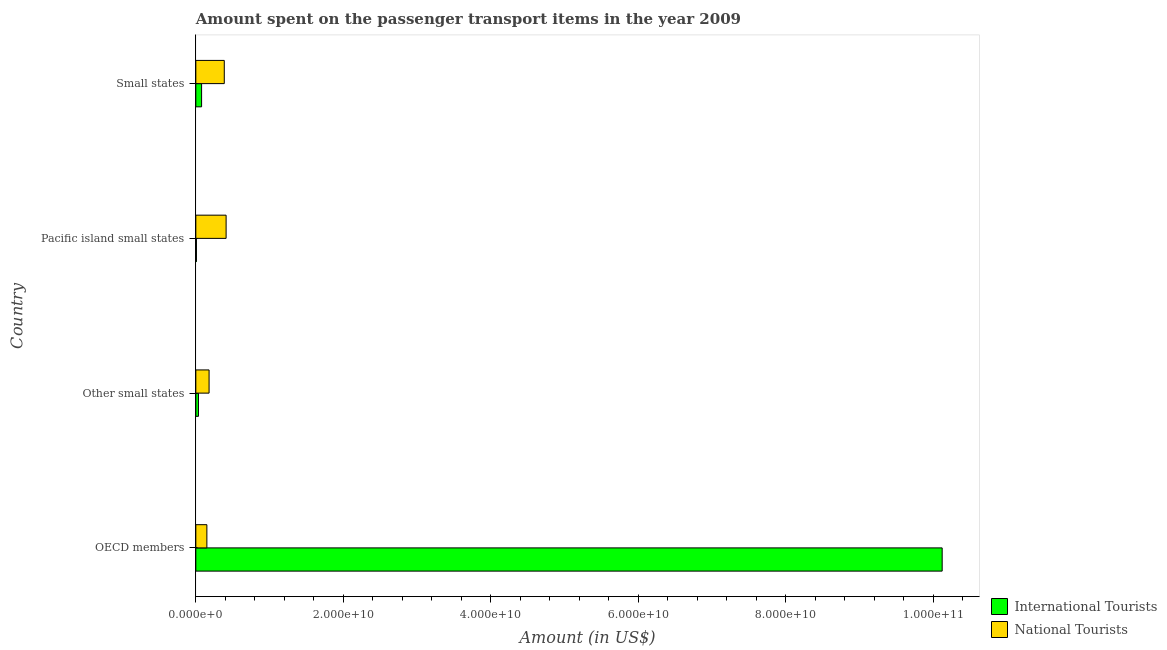How many different coloured bars are there?
Offer a very short reply. 2. How many groups of bars are there?
Your answer should be very brief. 4. How many bars are there on the 2nd tick from the top?
Provide a succinct answer. 2. How many bars are there on the 1st tick from the bottom?
Your answer should be compact. 2. What is the label of the 2nd group of bars from the top?
Give a very brief answer. Pacific island small states. What is the amount spent on transport items of international tourists in Small states?
Provide a succinct answer. 7.81e+08. Across all countries, what is the maximum amount spent on transport items of international tourists?
Offer a very short reply. 1.01e+11. Across all countries, what is the minimum amount spent on transport items of international tourists?
Give a very brief answer. 8.34e+07. In which country was the amount spent on transport items of international tourists maximum?
Offer a terse response. OECD members. In which country was the amount spent on transport items of international tourists minimum?
Give a very brief answer. Pacific island small states. What is the total amount spent on transport items of international tourists in the graph?
Keep it short and to the point. 1.02e+11. What is the difference between the amount spent on transport items of international tourists in OECD members and that in Other small states?
Give a very brief answer. 1.01e+11. What is the difference between the amount spent on transport items of national tourists in Pacific island small states and the amount spent on transport items of international tourists in OECD members?
Offer a very short reply. -9.71e+1. What is the average amount spent on transport items of national tourists per country?
Offer a very short reply. 2.82e+09. What is the difference between the amount spent on transport items of international tourists and amount spent on transport items of national tourists in Pacific island small states?
Your answer should be very brief. -4.02e+09. What is the ratio of the amount spent on transport items of national tourists in Other small states to that in Small states?
Provide a succinct answer. 0.47. What is the difference between the highest and the second highest amount spent on transport items of international tourists?
Ensure brevity in your answer.  1.00e+11. What is the difference between the highest and the lowest amount spent on transport items of national tourists?
Offer a very short reply. 2.61e+09. In how many countries, is the amount spent on transport items of international tourists greater than the average amount spent on transport items of international tourists taken over all countries?
Your answer should be compact. 1. Is the sum of the amount spent on transport items of national tourists in Pacific island small states and Small states greater than the maximum amount spent on transport items of international tourists across all countries?
Offer a very short reply. No. What does the 1st bar from the top in Pacific island small states represents?
Your response must be concise. National Tourists. What does the 2nd bar from the bottom in Small states represents?
Provide a short and direct response. National Tourists. Are all the bars in the graph horizontal?
Ensure brevity in your answer.  Yes. What is the title of the graph?
Make the answer very short. Amount spent on the passenger transport items in the year 2009. What is the Amount (in US$) of International Tourists in OECD members?
Provide a short and direct response. 1.01e+11. What is the Amount (in US$) in National Tourists in OECD members?
Your answer should be very brief. 1.50e+09. What is the Amount (in US$) in International Tourists in Other small states?
Give a very brief answer. 3.59e+08. What is the Amount (in US$) of National Tourists in Other small states?
Your response must be concise. 1.80e+09. What is the Amount (in US$) of International Tourists in Pacific island small states?
Keep it short and to the point. 8.34e+07. What is the Amount (in US$) of National Tourists in Pacific island small states?
Ensure brevity in your answer.  4.11e+09. What is the Amount (in US$) of International Tourists in Small states?
Provide a succinct answer. 7.81e+08. What is the Amount (in US$) in National Tourists in Small states?
Provide a succinct answer. 3.86e+09. Across all countries, what is the maximum Amount (in US$) of International Tourists?
Your answer should be compact. 1.01e+11. Across all countries, what is the maximum Amount (in US$) of National Tourists?
Your answer should be very brief. 4.11e+09. Across all countries, what is the minimum Amount (in US$) in International Tourists?
Ensure brevity in your answer.  8.34e+07. Across all countries, what is the minimum Amount (in US$) of National Tourists?
Offer a terse response. 1.50e+09. What is the total Amount (in US$) of International Tourists in the graph?
Offer a very short reply. 1.02e+11. What is the total Amount (in US$) in National Tourists in the graph?
Provide a succinct answer. 1.13e+1. What is the difference between the Amount (in US$) of International Tourists in OECD members and that in Other small states?
Your answer should be very brief. 1.01e+11. What is the difference between the Amount (in US$) in National Tourists in OECD members and that in Other small states?
Your answer should be compact. -2.99e+08. What is the difference between the Amount (in US$) of International Tourists in OECD members and that in Pacific island small states?
Provide a succinct answer. 1.01e+11. What is the difference between the Amount (in US$) in National Tourists in OECD members and that in Pacific island small states?
Make the answer very short. -2.61e+09. What is the difference between the Amount (in US$) of International Tourists in OECD members and that in Small states?
Give a very brief answer. 1.00e+11. What is the difference between the Amount (in US$) in National Tourists in OECD members and that in Small states?
Provide a succinct answer. -2.36e+09. What is the difference between the Amount (in US$) in International Tourists in Other small states and that in Pacific island small states?
Provide a short and direct response. 2.75e+08. What is the difference between the Amount (in US$) of National Tourists in Other small states and that in Pacific island small states?
Offer a very short reply. -2.31e+09. What is the difference between the Amount (in US$) in International Tourists in Other small states and that in Small states?
Give a very brief answer. -4.22e+08. What is the difference between the Amount (in US$) of National Tourists in Other small states and that in Small states?
Keep it short and to the point. -2.06e+09. What is the difference between the Amount (in US$) in International Tourists in Pacific island small states and that in Small states?
Provide a short and direct response. -6.98e+08. What is the difference between the Amount (in US$) in National Tourists in Pacific island small states and that in Small states?
Your answer should be compact. 2.48e+08. What is the difference between the Amount (in US$) of International Tourists in OECD members and the Amount (in US$) of National Tourists in Other small states?
Offer a very short reply. 9.94e+1. What is the difference between the Amount (in US$) in International Tourists in OECD members and the Amount (in US$) in National Tourists in Pacific island small states?
Give a very brief answer. 9.71e+1. What is the difference between the Amount (in US$) of International Tourists in OECD members and the Amount (in US$) of National Tourists in Small states?
Give a very brief answer. 9.74e+1. What is the difference between the Amount (in US$) of International Tourists in Other small states and the Amount (in US$) of National Tourists in Pacific island small states?
Make the answer very short. -3.75e+09. What is the difference between the Amount (in US$) in International Tourists in Other small states and the Amount (in US$) in National Tourists in Small states?
Ensure brevity in your answer.  -3.50e+09. What is the difference between the Amount (in US$) of International Tourists in Pacific island small states and the Amount (in US$) of National Tourists in Small states?
Provide a short and direct response. -3.78e+09. What is the average Amount (in US$) in International Tourists per country?
Provide a succinct answer. 2.56e+1. What is the average Amount (in US$) of National Tourists per country?
Keep it short and to the point. 2.82e+09. What is the difference between the Amount (in US$) of International Tourists and Amount (in US$) of National Tourists in OECD members?
Give a very brief answer. 9.97e+1. What is the difference between the Amount (in US$) of International Tourists and Amount (in US$) of National Tourists in Other small states?
Offer a terse response. -1.44e+09. What is the difference between the Amount (in US$) in International Tourists and Amount (in US$) in National Tourists in Pacific island small states?
Give a very brief answer. -4.02e+09. What is the difference between the Amount (in US$) of International Tourists and Amount (in US$) of National Tourists in Small states?
Keep it short and to the point. -3.08e+09. What is the ratio of the Amount (in US$) in International Tourists in OECD members to that in Other small states?
Provide a succinct answer. 282.13. What is the ratio of the Amount (in US$) of National Tourists in OECD members to that in Other small states?
Provide a succinct answer. 0.83. What is the ratio of the Amount (in US$) of International Tourists in OECD members to that in Pacific island small states?
Keep it short and to the point. 1213.66. What is the ratio of the Amount (in US$) in National Tourists in OECD members to that in Pacific island small states?
Provide a short and direct response. 0.36. What is the ratio of the Amount (in US$) of International Tourists in OECD members to that in Small states?
Give a very brief answer. 129.62. What is the ratio of the Amount (in US$) of National Tourists in OECD members to that in Small states?
Give a very brief answer. 0.39. What is the ratio of the Amount (in US$) of International Tourists in Other small states to that in Pacific island small states?
Your response must be concise. 4.3. What is the ratio of the Amount (in US$) in National Tourists in Other small states to that in Pacific island small states?
Provide a succinct answer. 0.44. What is the ratio of the Amount (in US$) of International Tourists in Other small states to that in Small states?
Keep it short and to the point. 0.46. What is the ratio of the Amount (in US$) in National Tourists in Other small states to that in Small states?
Provide a succinct answer. 0.47. What is the ratio of the Amount (in US$) in International Tourists in Pacific island small states to that in Small states?
Your answer should be compact. 0.11. What is the ratio of the Amount (in US$) in National Tourists in Pacific island small states to that in Small states?
Give a very brief answer. 1.06. What is the difference between the highest and the second highest Amount (in US$) in International Tourists?
Your response must be concise. 1.00e+11. What is the difference between the highest and the second highest Amount (in US$) in National Tourists?
Make the answer very short. 2.48e+08. What is the difference between the highest and the lowest Amount (in US$) in International Tourists?
Ensure brevity in your answer.  1.01e+11. What is the difference between the highest and the lowest Amount (in US$) of National Tourists?
Keep it short and to the point. 2.61e+09. 